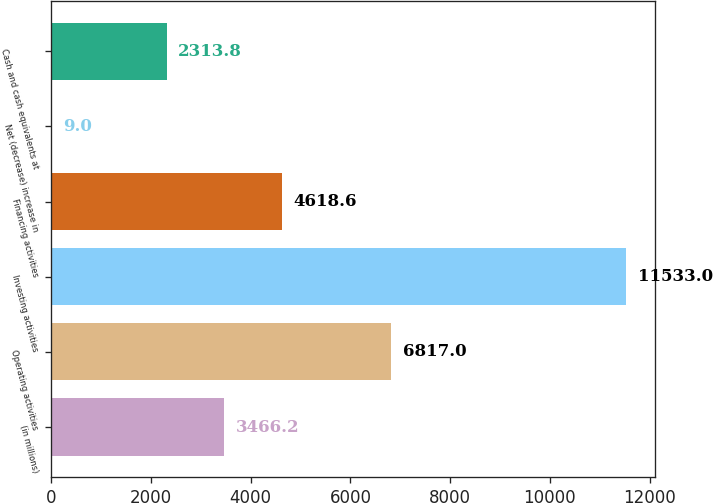Convert chart. <chart><loc_0><loc_0><loc_500><loc_500><bar_chart><fcel>(in millions)<fcel>Operating activities<fcel>Investing activities<fcel>Financing activities<fcel>Net (decrease) increase in<fcel>Cash and cash equivalents at<nl><fcel>3466.2<fcel>6817<fcel>11533<fcel>4618.6<fcel>9<fcel>2313.8<nl></chart> 